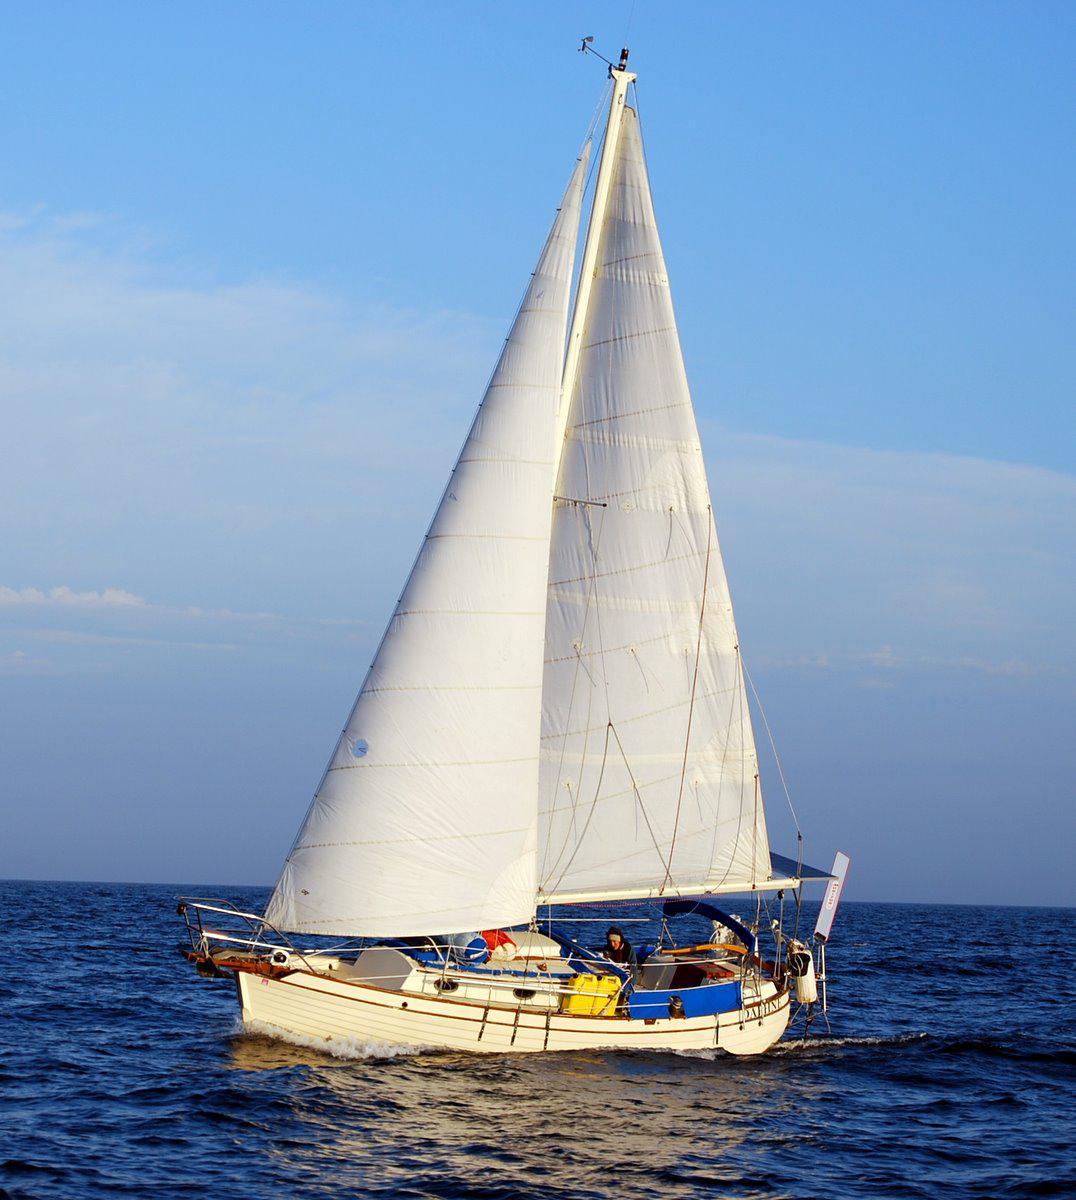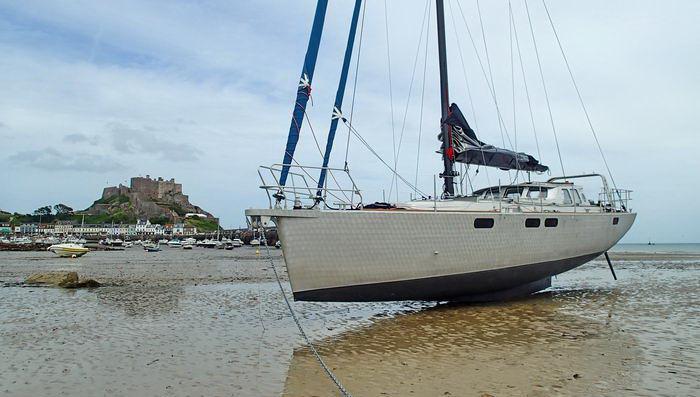The first image is the image on the left, the second image is the image on the right. For the images shown, is this caption "One sailboat is on the open water with its sails folded down." true? Answer yes or no. No. 